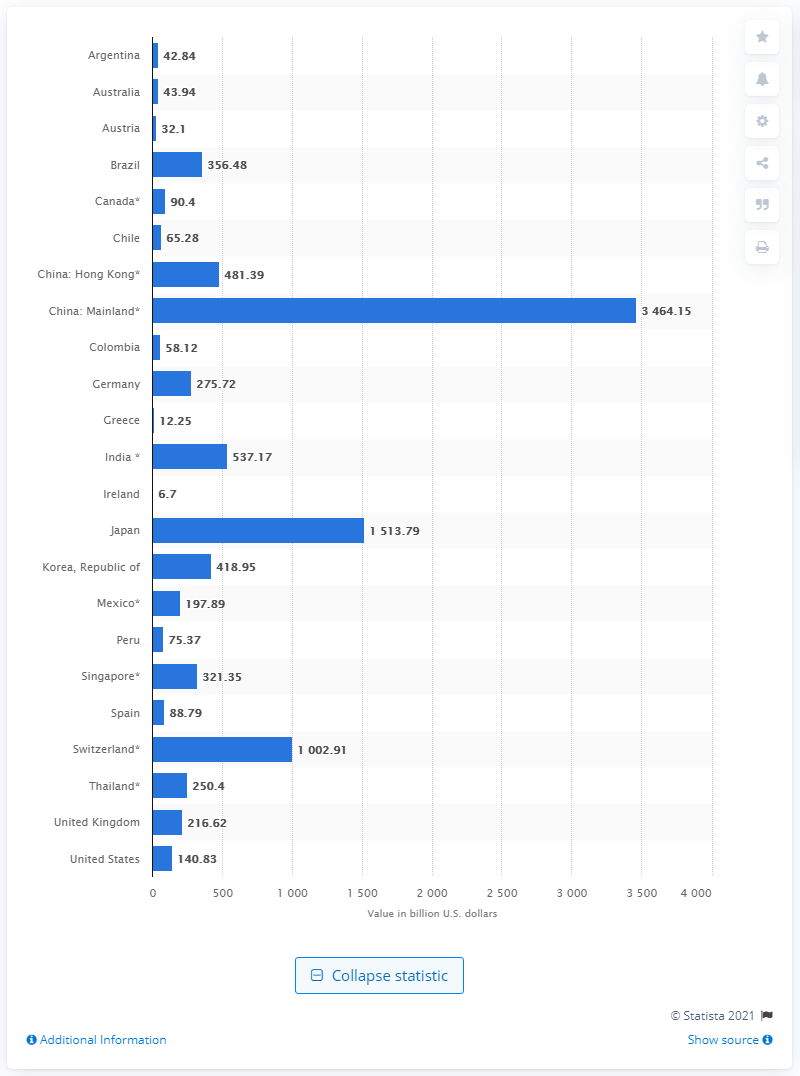How many U.S. dollars did China have in reserves in August 2020? As of August 2020, China had reserves amounting to approximately 3.464 trillion U.S. dollars, according to the data presented in the image. This puts China in a position of significant financial influence globally, with the largest foreign-exchange reserves in the world. 